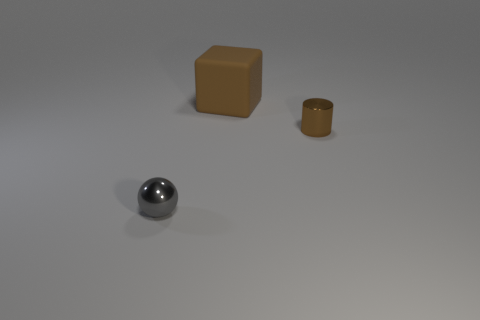Can you describe the texture and possible material of the gray object in the foreground? The gray object in the foreground has a smooth, reflective surface, indicating it could be made of polished metal or a similar lustrous material. 